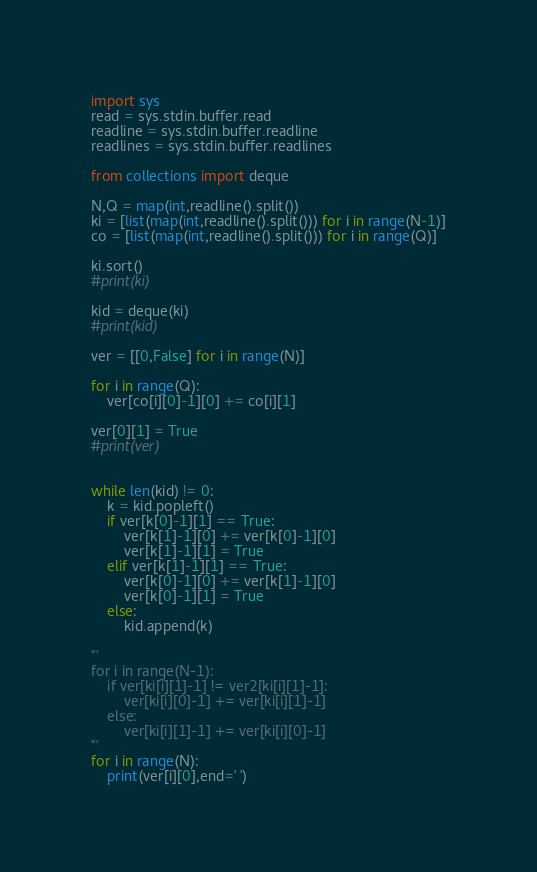<code> <loc_0><loc_0><loc_500><loc_500><_Python_>import sys
read = sys.stdin.buffer.read
readline = sys.stdin.buffer.readline
readlines = sys.stdin.buffer.readlines

from collections import deque

N,Q = map(int,readline().split())
ki = [list(map(int,readline().split())) for i in range(N-1)]
co = [list(map(int,readline().split())) for i in range(Q)]
 
ki.sort()
#print(ki)

kid = deque(ki)
#print(kid)
 
ver = [[0,False] for i in range(N)]
 
for i in range(Q):
    ver[co[i][0]-1][0] += co[i][1]

ver[0][1] = True
#print(ver)


while len(kid) != 0:
    k = kid.popleft()
    if ver[k[0]-1][1] == True:
        ver[k[1]-1][0] += ver[k[0]-1][0]
        ver[k[1]-1][1] = True
    elif ver[k[1]-1][1] == True:
        ver[k[0]-1][0] += ver[k[1]-1][0]
        ver[k[0]-1][1] = True
    else:
        kid.append(k)

'''
for i in range(N-1):
    if ver[ki[i][1]-1] != ver2[ki[i][1]-1]:
        ver[ki[i][0]-1] += ver[ki[i][1]-1]
    else:
        ver[ki[i][1]-1] += ver[ki[i][0]-1]
'''
for i in range(N):
    print(ver[i][0],end=' ')
</code> 